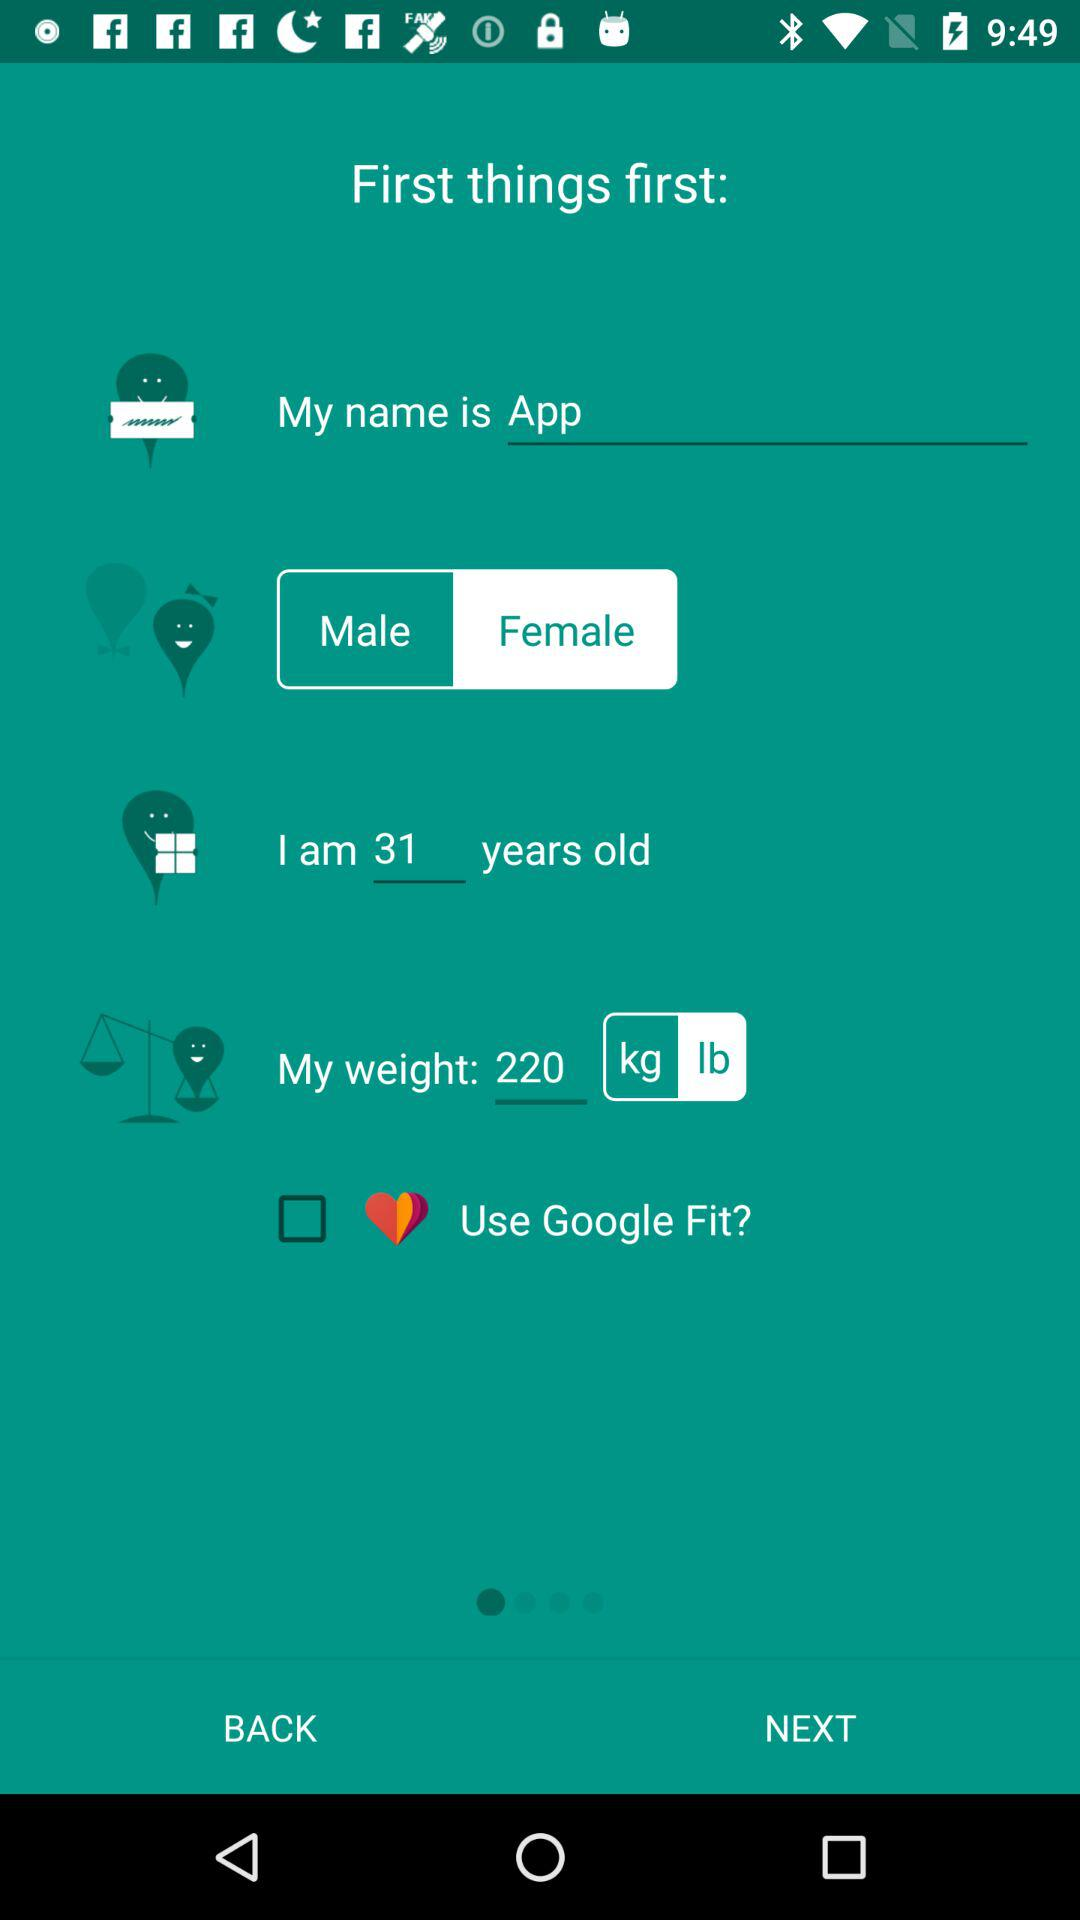What is the name? The name is App. 